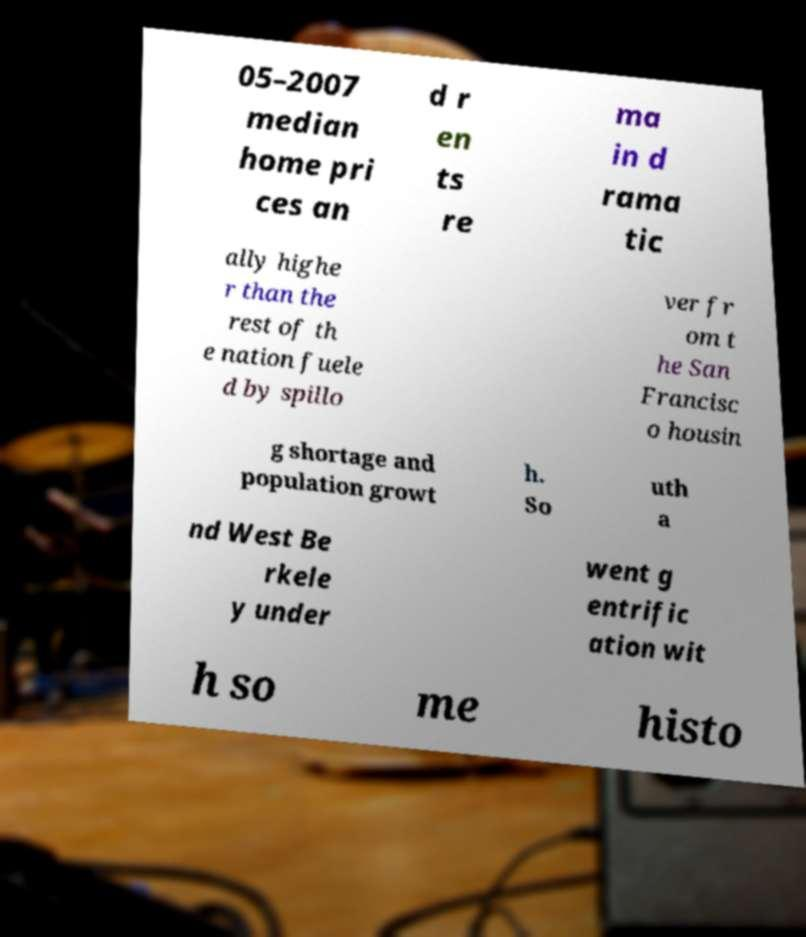Please read and relay the text visible in this image. What does it say? 05–2007 median home pri ces an d r en ts re ma in d rama tic ally highe r than the rest of th e nation fuele d by spillo ver fr om t he San Francisc o housin g shortage and population growt h. So uth a nd West Be rkele y under went g entrific ation wit h so me histo 